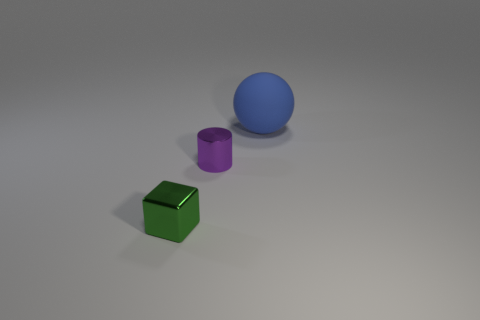Are there any other things that have the same color as the metal cylinder?
Offer a terse response. No. How big is the metal thing that is in front of the tiny thing behind the tiny thing to the left of the purple cylinder?
Your answer should be very brief. Small. There is a thing that is both left of the blue matte thing and to the right of the block; what is its color?
Offer a very short reply. Purple. There is a metallic object that is behind the metallic block; how big is it?
Keep it short and to the point. Small. What number of large spheres have the same material as the tiny purple object?
Provide a succinct answer. 0. There is a tiny block that is the same material as the small purple thing; what color is it?
Keep it short and to the point. Green. There is a large ball behind the tiny object that is in front of the purple shiny object; is there a purple cylinder that is in front of it?
Your response must be concise. Yes. The green metallic object is what shape?
Your answer should be compact. Cube. Is the number of cubes that are to the left of the green thing less than the number of green metal things?
Provide a succinct answer. Yes. What shape is the thing that is the same size as the purple cylinder?
Make the answer very short. Cube. 